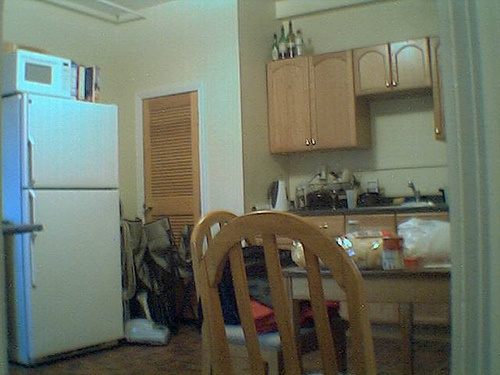Describe the objects in this image and their specific colors. I can see refrigerator in gray, darkgray, and lightblue tones, chair in gray and black tones, dining table in gray, black, and darkgray tones, microwave in gray, lightblue, cyan, and darkgray tones, and chair in gray and darkgray tones in this image. 